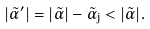<formula> <loc_0><loc_0><loc_500><loc_500>\left | \tilde { \alpha } ^ { \prime } \right | = | \tilde { \alpha } | - \tilde { \alpha } _ { j } < | \tilde { \alpha } | .</formula> 